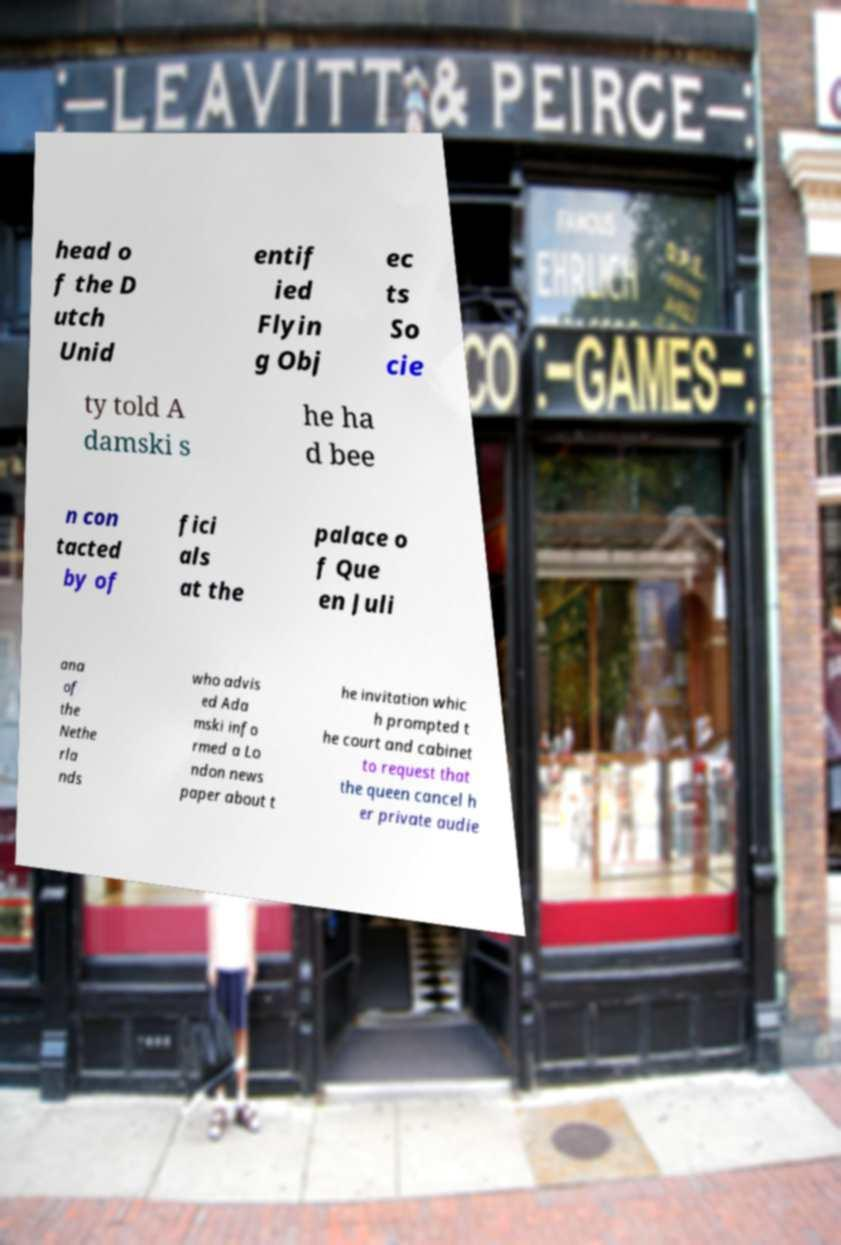Could you assist in decoding the text presented in this image and type it out clearly? head o f the D utch Unid entif ied Flyin g Obj ec ts So cie ty told A damski s he ha d bee n con tacted by of fici als at the palace o f Que en Juli ana of the Nethe rla nds who advis ed Ada mski info rmed a Lo ndon news paper about t he invitation whic h prompted t he court and cabinet to request that the queen cancel h er private audie 